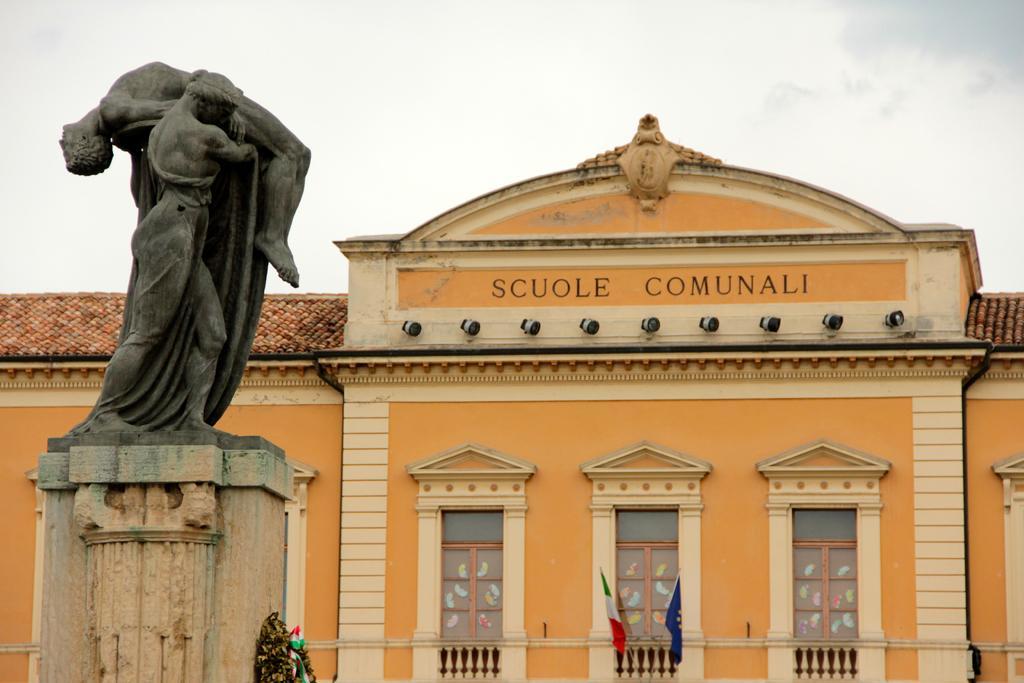Describe this image in one or two sentences. In this image I can see the statue which is in black color. To the side of the statue I can see the building which is in brown and yellow color. I can see the windows and the flags to the building. In the background I can see the clouds and the sky. 